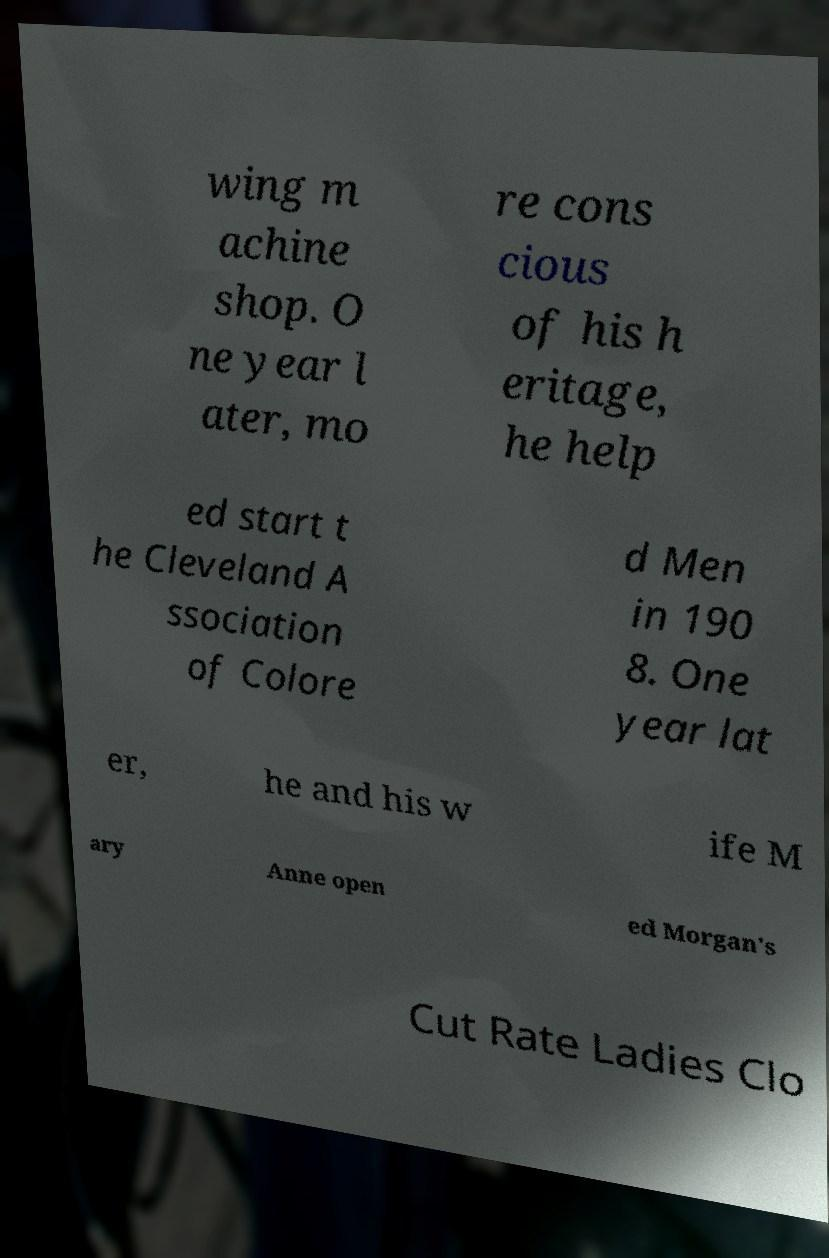What messages or text are displayed in this image? I need them in a readable, typed format. wing m achine shop. O ne year l ater, mo re cons cious of his h eritage, he help ed start t he Cleveland A ssociation of Colore d Men in 190 8. One year lat er, he and his w ife M ary Anne open ed Morgan's Cut Rate Ladies Clo 